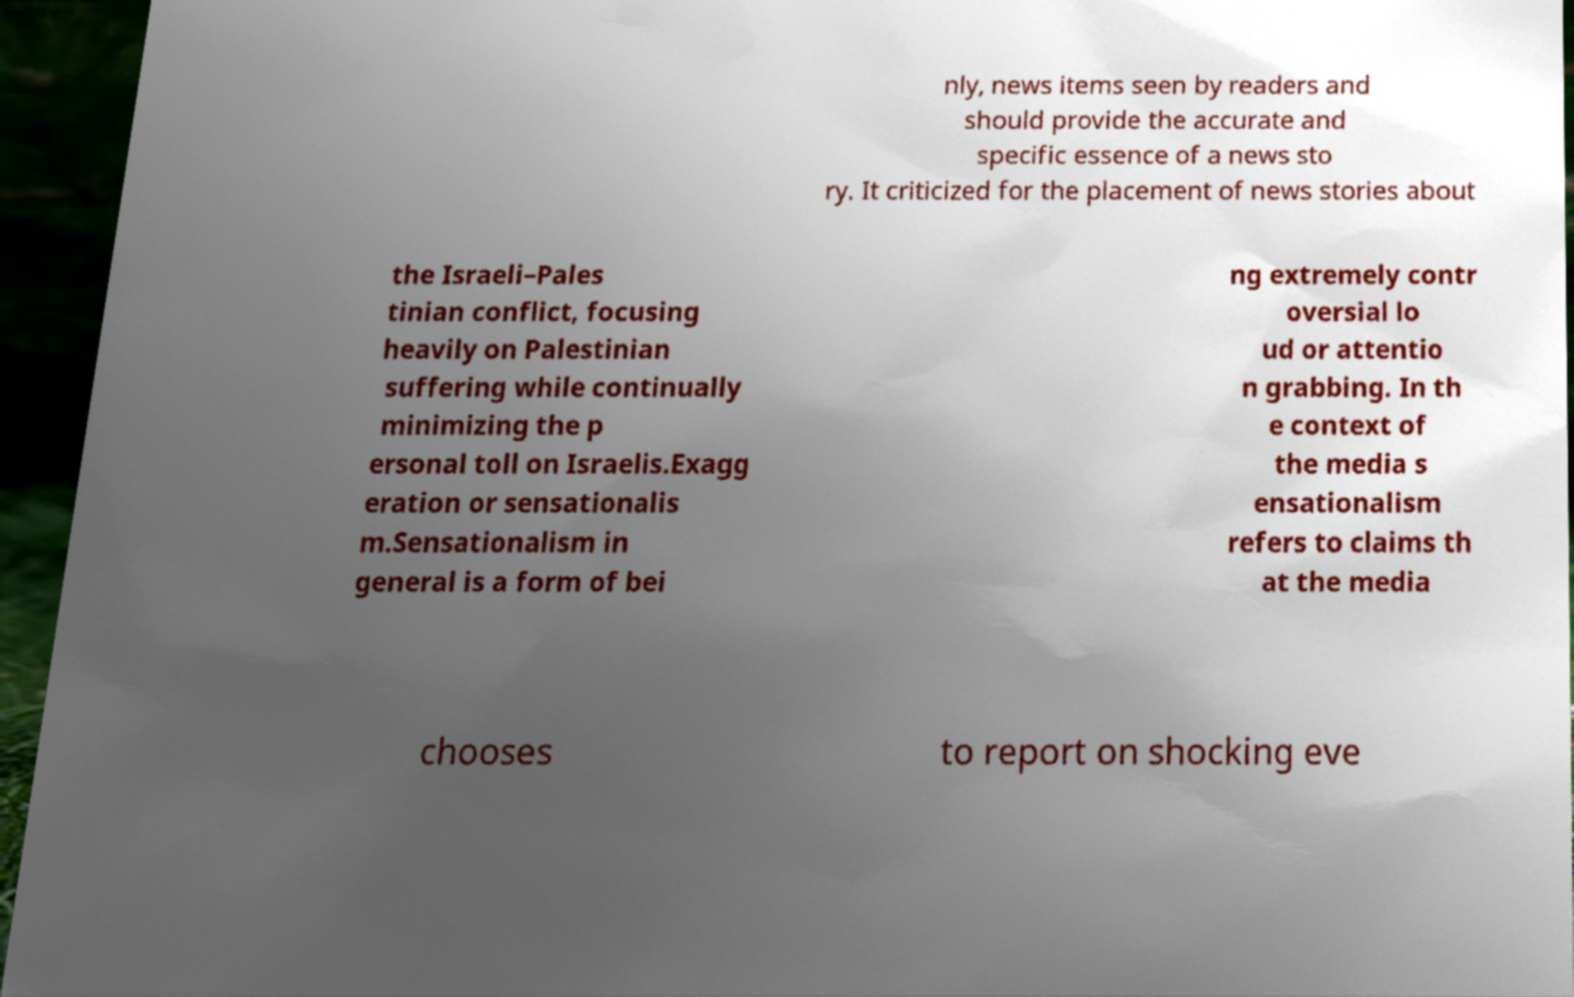Can you accurately transcribe the text from the provided image for me? nly, news items seen by readers and should provide the accurate and specific essence of a news sto ry. It criticized for the placement of news stories about the Israeli–Pales tinian conflict, focusing heavily on Palestinian suffering while continually minimizing the p ersonal toll on Israelis.Exagg eration or sensationalis m.Sensationalism in general is a form of bei ng extremely contr oversial lo ud or attentio n grabbing. In th e context of the media s ensationalism refers to claims th at the media chooses to report on shocking eve 